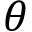<formula> <loc_0><loc_0><loc_500><loc_500>\theta</formula> 